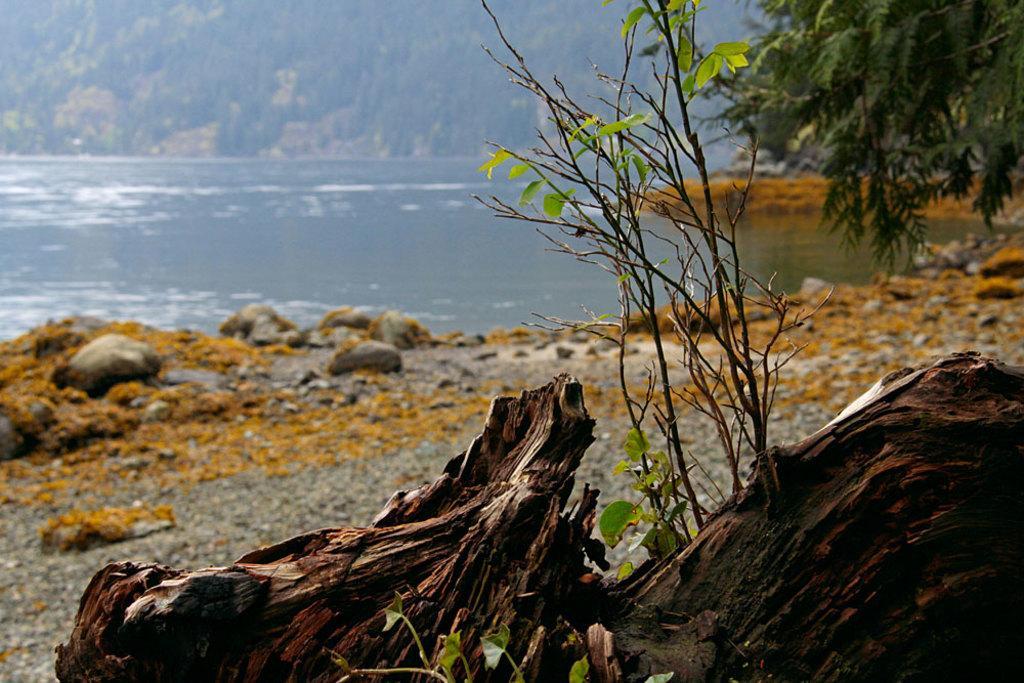Describe this image in one or two sentences. At the bottom of the picture, we see trees and a wood. Beside that, we see the stones. In the right top of the picture, we see trees. We see water and this water might be in the lake. There are trees in the background. 